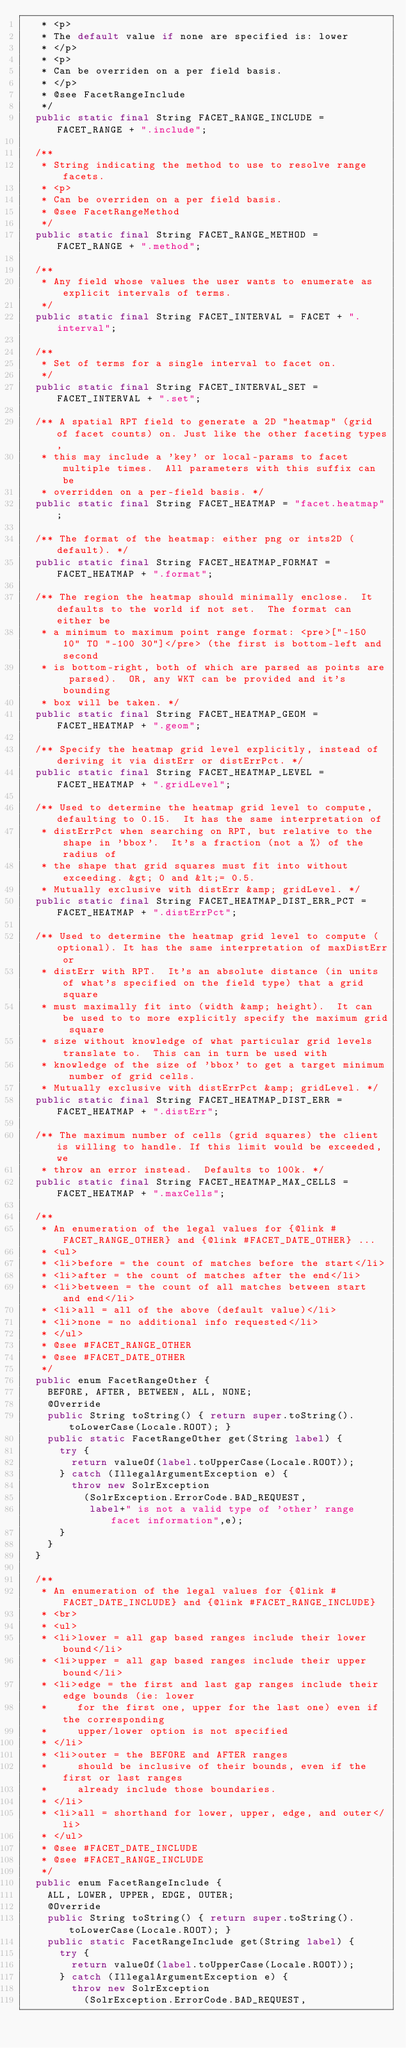<code> <loc_0><loc_0><loc_500><loc_500><_Java_>   * <p>
   * The default value if none are specified is: lower
   * </p>
   * <p>
   * Can be overriden on a per field basis.
   * </p>
   * @see FacetRangeInclude
   */
  public static final String FACET_RANGE_INCLUDE = FACET_RANGE + ".include";
  
  /**
   * String indicating the method to use to resolve range facets.
   * <p>
   * Can be overriden on a per field basis.
   * @see FacetRangeMethod
   */
  public static final String FACET_RANGE_METHOD = FACET_RANGE + ".method";
  
  /**
   * Any field whose values the user wants to enumerate as explicit intervals of terms.
   */
  public static final String FACET_INTERVAL = FACET + ".interval";

  /**
   * Set of terms for a single interval to facet on.
   */
  public static final String FACET_INTERVAL_SET = FACET_INTERVAL + ".set";

  /** A spatial RPT field to generate a 2D "heatmap" (grid of facet counts) on. Just like the other faceting types,
   * this may include a 'key' or local-params to facet multiple times.  All parameters with this suffix can be
   * overridden on a per-field basis. */
  public static final String FACET_HEATMAP = "facet.heatmap";

  /** The format of the heatmap: either png or ints2D (default). */
  public static final String FACET_HEATMAP_FORMAT = FACET_HEATMAP + ".format";

  /** The region the heatmap should minimally enclose.  It defaults to the world if not set.  The format can either be
   * a minimum to maximum point range format: <pre>["-150 10" TO "-100 30"]</pre> (the first is bottom-left and second
   * is bottom-right, both of which are parsed as points are parsed).  OR, any WKT can be provided and it's bounding
   * box will be taken. */
  public static final String FACET_HEATMAP_GEOM = FACET_HEATMAP + ".geom";

  /** Specify the heatmap grid level explicitly, instead of deriving it via distErr or distErrPct. */
  public static final String FACET_HEATMAP_LEVEL = FACET_HEATMAP + ".gridLevel";

  /** Used to determine the heatmap grid level to compute, defaulting to 0.15.  It has the same interpretation of
   * distErrPct when searching on RPT, but relative to the shape in 'bbox'.  It's a fraction (not a %) of the radius of
   * the shape that grid squares must fit into without exceeding. &gt; 0 and &lt;= 0.5.
   * Mutually exclusive with distErr &amp; gridLevel. */
  public static final String FACET_HEATMAP_DIST_ERR_PCT = FACET_HEATMAP + ".distErrPct";

  /** Used to determine the heatmap grid level to compute (optional). It has the same interpretation of maxDistErr or
   * distErr with RPT.  It's an absolute distance (in units of what's specified on the field type) that a grid square
   * must maximally fit into (width &amp; height).  It can be used to to more explicitly specify the maximum grid square
   * size without knowledge of what particular grid levels translate to.  This can in turn be used with
   * knowledge of the size of 'bbox' to get a target minimum number of grid cells.
   * Mutually exclusive with distErrPct &amp; gridLevel. */
  public static final String FACET_HEATMAP_DIST_ERR = FACET_HEATMAP + ".distErr";

  /** The maximum number of cells (grid squares) the client is willing to handle. If this limit would be exceeded, we
   * throw an error instead.  Defaults to 100k. */
  public static final String FACET_HEATMAP_MAX_CELLS = FACET_HEATMAP + ".maxCells";

  /**
   * An enumeration of the legal values for {@link #FACET_RANGE_OTHER} and {@link #FACET_DATE_OTHER} ...
   * <ul>
   * <li>before = the count of matches before the start</li>
   * <li>after = the count of matches after the end</li>
   * <li>between = the count of all matches between start and end</li>
   * <li>all = all of the above (default value)</li>
   * <li>none = no additional info requested</li>
   * </ul>
   * @see #FACET_RANGE_OTHER
   * @see #FACET_DATE_OTHER
   */
  public enum FacetRangeOther {
    BEFORE, AFTER, BETWEEN, ALL, NONE;
    @Override
    public String toString() { return super.toString().toLowerCase(Locale.ROOT); }
    public static FacetRangeOther get(String label) {
      try {
        return valueOf(label.toUpperCase(Locale.ROOT));
      } catch (IllegalArgumentException e) {
        throw new SolrException
          (SolrException.ErrorCode.BAD_REQUEST,
           label+" is not a valid type of 'other' range facet information",e);
      }
    }
  }
  
  /**
   * An enumeration of the legal values for {@link #FACET_DATE_INCLUDE} and {@link #FACET_RANGE_INCLUDE}
   * <br>
   * <ul>
   * <li>lower = all gap based ranges include their lower bound</li>
   * <li>upper = all gap based ranges include their upper bound</li>
   * <li>edge = the first and last gap ranges include their edge bounds (ie: lower 
   *     for the first one, upper for the last one) even if the corresponding 
   *     upper/lower option is not specified
   * </li>
   * <li>outer = the BEFORE and AFTER ranges 
   *     should be inclusive of their bounds, even if the first or last ranges 
   *     already include those boundaries.
   * </li>
   * <li>all = shorthand for lower, upper, edge, and outer</li>
   * </ul>
   * @see #FACET_DATE_INCLUDE
   * @see #FACET_RANGE_INCLUDE
   */
  public enum FacetRangeInclude {
    ALL, LOWER, UPPER, EDGE, OUTER;
    @Override
    public String toString() { return super.toString().toLowerCase(Locale.ROOT); }
    public static FacetRangeInclude get(String label) {
      try {
        return valueOf(label.toUpperCase(Locale.ROOT));
      } catch (IllegalArgumentException e) {
        throw new SolrException
          (SolrException.ErrorCode.BAD_REQUEST,</code> 